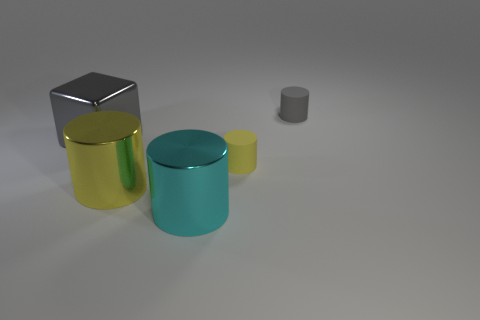There is a yellow cylinder that is the same size as the gray cylinder; what is it made of?
Ensure brevity in your answer.  Rubber. There is a big shiny thing behind the small rubber thing in front of the cube; how many objects are in front of it?
Make the answer very short. 3. Is the color of the shiny cylinder behind the cyan shiny cylinder the same as the small rubber thing that is in front of the large gray metallic block?
Your answer should be very brief. Yes. What is the color of the thing that is both behind the tiny yellow matte thing and on the left side of the tiny yellow rubber cylinder?
Provide a succinct answer. Gray. How many cylinders are the same size as the yellow metal object?
Provide a short and direct response. 1. There is a gray thing in front of the small object to the right of the tiny yellow cylinder; what is its shape?
Your response must be concise. Cube. There is a gray thing that is to the left of the rubber cylinder that is in front of the gray thing that is left of the small gray cylinder; what shape is it?
Offer a very short reply. Cube. What number of gray objects have the same shape as the cyan metallic object?
Give a very brief answer. 1. How many tiny gray matte cylinders are to the left of the matte cylinder behind the yellow rubber cylinder?
Make the answer very short. 0. How many metallic objects are either tiny gray things or cylinders?
Ensure brevity in your answer.  2. 